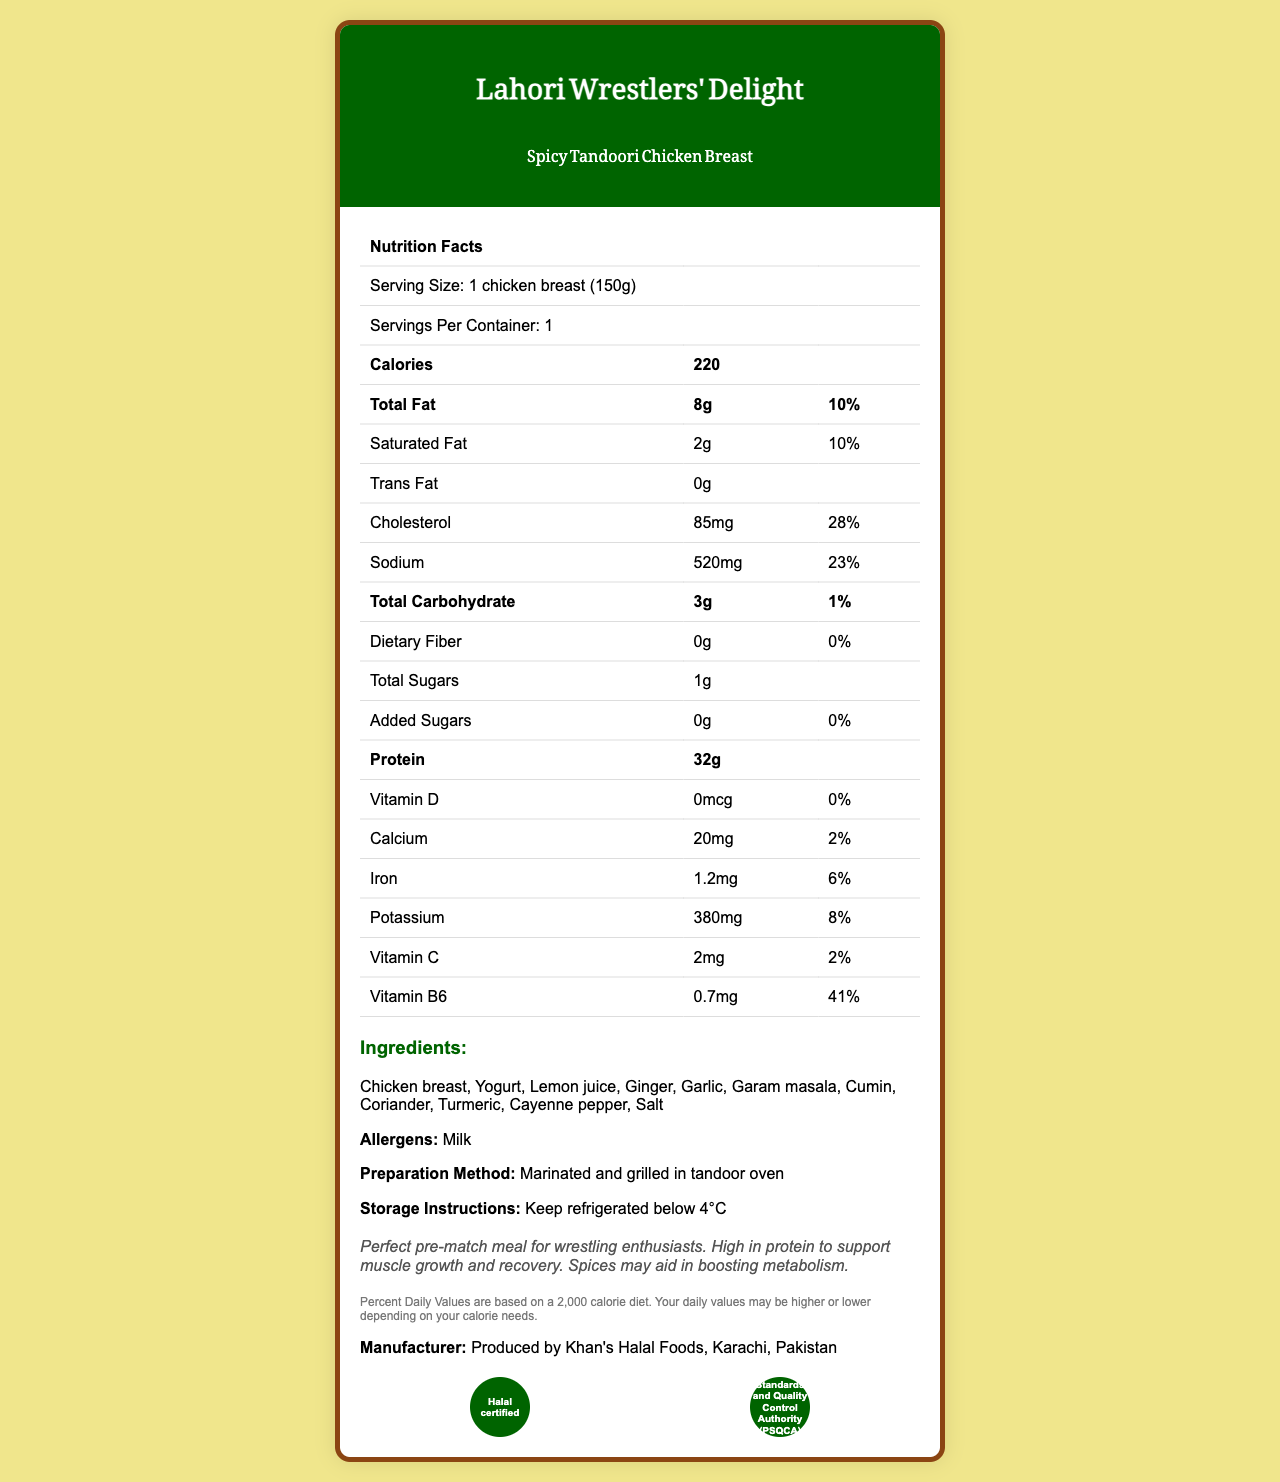who produces the Spicy Tandoori Chicken Breast? The manufacturer information states it is produced by Khan's Halal Foods, Karachi, Pakistan.
Answer: Khan's Halal Foods what is the serving size of the Spicy Tandoori Chicken Breast? The nutrition facts label indicates that the serving size is 1 chicken breast (150g).
Answer: 1 chicken breast (150g) how many grams of total fat are there per serving? The document lists the total fat content as 8g per serving.
Answer: 8g what is the percentage of daily value for cholesterol in a serving? The nutrition facts specify that the cholesterol content of 85mg per serving is 28% of the daily value.
Answer: 28% which ingredient is listed first? The ingredients are listed with Chicken breast as the first ingredient.
Answer: Chicken breast what are the two certifications mentioned for the product? The document lists the certifications as "Halal certified" and "Pakistan Standards and Quality Control Authority (PSQCA) approved".
Answer: Halal certified, PSQCA approved what is the total protein content in a serving? A. 25g B. 30g C. 32g D. 35g The protein content per serving is listed as 32g, which corresponds to option C.
Answer: C. 32g which allergen is noted on the label? A. Gluten B. Milk C. Peanut D. Soy The document identifies Milk as an allergen, which matches option B.
Answer: B. Milk is the sodium content in this product more than 500mg per serving? The sodium content per serving is listed as 520mg, which is more than 500mg.
Answer: Yes summarize the main idea of this document. The document is primarily focused on providing comprehensive nutritional information about the Spicy Tandoori Chicken Breast, its ingredients, certifications, and additional relevant details for consumers.
Answer: The document provides detailed nutritional information for a spicy tandoori chicken breast produced by Khan's Halal Foods. It highlights the serving size, calorie content, macronutrients, various vitamins and minerals, ingredients, allergens, certifications, preparation method, and storage instructions. It emphasizes the high protein content, making it an ideal pre-match meal for wrestling enthusiasts. is this product suitable for a vegetarian diet? There is not enough information in the document to determine the suitability of the product for a vegetarian diet, though chicken breast indicates it is not vegetarian.
Answer: Cannot be determined 